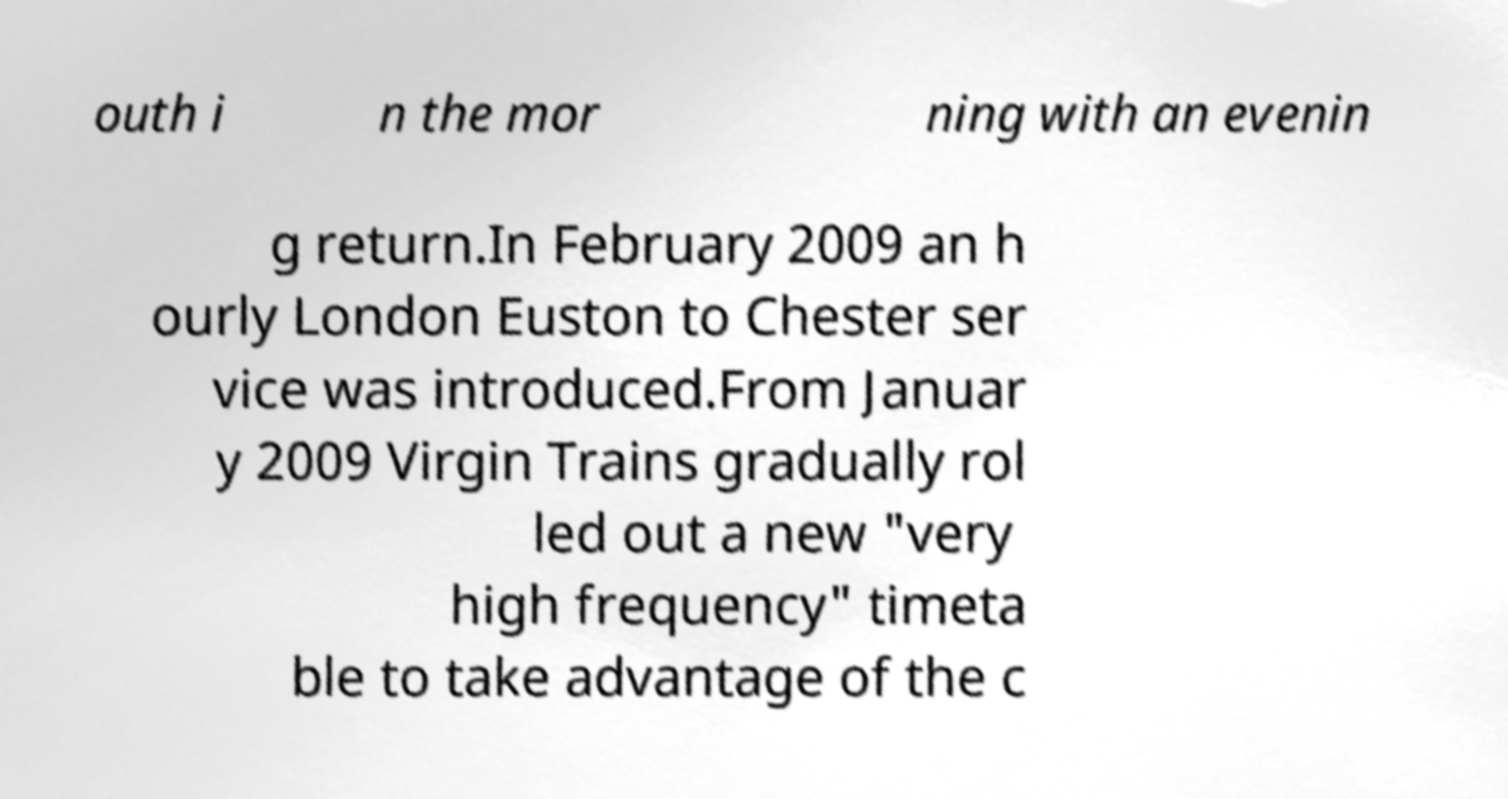What messages or text are displayed in this image? I need them in a readable, typed format. outh i n the mor ning with an evenin g return.In February 2009 an h ourly London Euston to Chester ser vice was introduced.From Januar y 2009 Virgin Trains gradually rol led out a new "very high frequency" timeta ble to take advantage of the c 